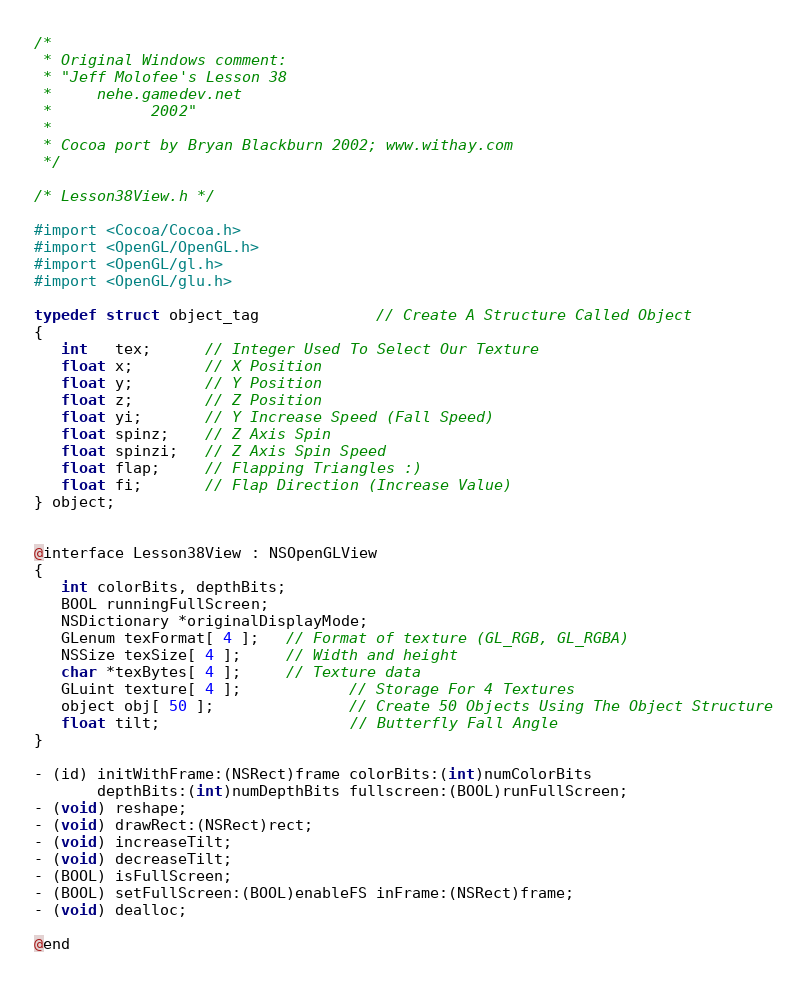Convert code to text. <code><loc_0><loc_0><loc_500><loc_500><_C_>/*
 * Original Windows comment:
 * "Jeff Molofee's Lesson 38
 *     nehe.gamedev.net
 *           2002"
 * 
 * Cocoa port by Bryan Blackburn 2002; www.withay.com
 */

/* Lesson38View.h */

#import <Cocoa/Cocoa.h>
#import <OpenGL/OpenGL.h>
#import <OpenGL/gl.h>
#import <OpenGL/glu.h>

typedef struct object_tag             // Create A Structure Called Object
{
   int   tex;      // Integer Used To Select Our Texture
   float x;        // X Position
   float y;        // Y Position
   float z;        // Z Position
   float yi;       // Y Increase Speed (Fall Speed)
   float spinz;    // Z Axis Spin
   float spinzi;   // Z Axis Spin Speed
   float flap;     // Flapping Triangles :)
   float fi;       // Flap Direction (Increase Value)
} object;


@interface Lesson38View : NSOpenGLView
{
   int colorBits, depthBits;
   BOOL runningFullScreen;
   NSDictionary *originalDisplayMode;
   GLenum texFormat[ 4 ];   // Format of texture (GL_RGB, GL_RGBA)
   NSSize texSize[ 4 ];     // Width and height
   char *texBytes[ 4 ];     // Texture data
   GLuint texture[ 4 ];            // Storage For 4 Textures
   object obj[ 50 ];               // Create 50 Objects Using The Object Structure
   float tilt;                     // Butterfly Fall Angle
}

- (id) initWithFrame:(NSRect)frame colorBits:(int)numColorBits
       depthBits:(int)numDepthBits fullscreen:(BOOL)runFullScreen;
- (void) reshape;
- (void) drawRect:(NSRect)rect;
- (void) increaseTilt;
- (void) decreaseTilt;
- (BOOL) isFullScreen;
- (BOOL) setFullScreen:(BOOL)enableFS inFrame:(NSRect)frame;
- (void) dealloc;

@end
</code> 